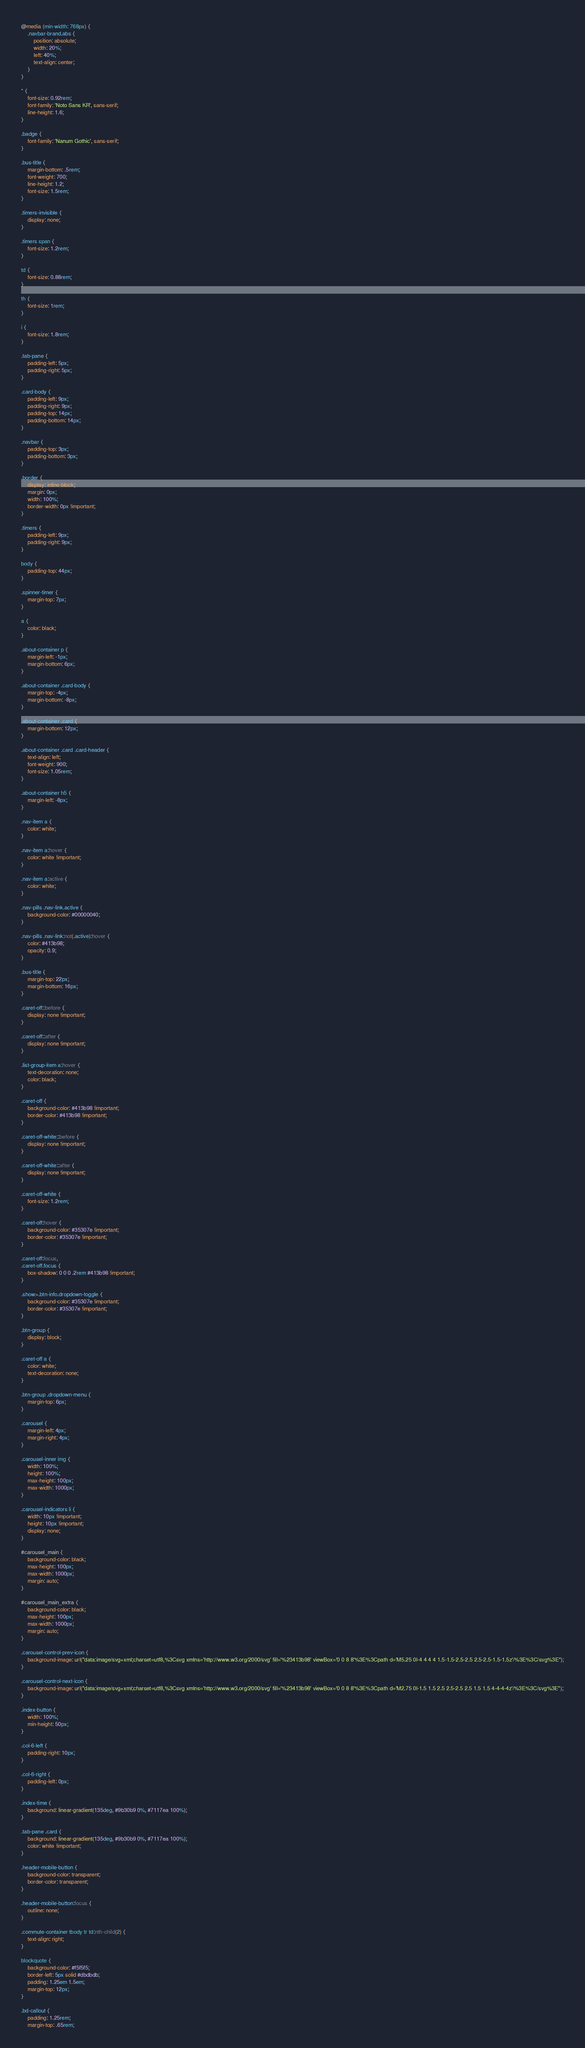Convert code to text. <code><loc_0><loc_0><loc_500><loc_500><_CSS_>@media (min-width: 768px) {
    .navbar-brand.abs {
        position: absolute;
        width: 20%;
        left: 40%;
        text-align: center;
    }
}

* {
    font-size: 0.92rem;
    font-family: 'Noto Sans KR', sans-serif;
    line-height: 1.6;
}

.badge {
    font-family: 'Nanum Gothic', sans-serif;
}

.bus-title {
    margin-bottom: .5rem;
    font-weight: 700;
    line-height: 1.2;
    font-size: 1.5rem;
}

.timers-invisible {
    display: none;
}

.timers span {
    font-size: 1.2rem;
}

td {
    font-size: 0.88rem;
}

th {
    font-size: 1rem;
}

i {
    font-size: 1.8rem;
}

.tab-pane {
    padding-left: 5px;
    padding-right: 5px;
}

.card-body {
    padding-left: 9px;
    padding-right: 9px;
    padding-top: 14px;
    padding-bottom: 14px;
}

.navbar {
    padding-top: 3px;
    padding-bottom: 3px;
}

.border {
    display: inline-block;
    margin: 0px;
    width: 100%;
    border-width: 0px !important;
}

.timers {
    padding-left: 9px;
    padding-right: 9px;
}

body {
    padding-top: 44px;
}

.spinner-timer {
    margin-top: 7px;
}

a {
    color: black;
}

.about-container p {
    margin-left: -1px;
    margin-bottom: 6px;
}

.about-container .card-body {
    margin-top: -4px;
    margin-bottom: -8px;
}

.about-container .card {
    margin-bottom: 12px;
}

.about-container .card .card-header {
    text-align: left;
    font-weight: 900;
    font-size: 1.05rem;
}

.about-container h5 {
    margin-left: -8px;
}

.nav-item a {
    color: white;
}

.nav-item a:hover {
    color: white !important;
}

.nav-item a:active {
    color: white;
}

.nav-pills .nav-link.active {
    background-color: #00000040;
}

.nav-pills .nav-link:not(.active):hover {
    color: #413b98;
    opacity: 0.9;
}

.bus-title {
    margin-top: 22px;
    margin-bottom: 16px;
}

.caret-off::before {
    display: none !important;
}

.caret-off::after {
    display: none !important;
}

.list-group-item a:hover {
    text-decoration: none;
    color: black;
}

.caret-off {
    background-color: #413b98 !important;
    border-color: #413b98 !important;
}

.caret-off-white::before {
    display: none !important;
}

.caret-off-white::after {
    display: none !important;
}

.caret-off-white {
    font-size: 1.2rem;
}

.caret-off:hover {
    background-color: #35307e !important;
    border-color: #35307e !important;
}

.caret-off:focus,
.caret-off.focus {
    box-shadow: 0 0 0 .2rem #413b98 !important;
}

.show>.btn-info.dropdown-toggle {
    background-color: #35307e !important;
    border-color: #35307e !important;
}

.btn-group {
    display: block;
}

.caret-off a {
    color: white;
    text-decoration: none;
}

.btn-group .dropdown-menu {
    margin-top: 6px;
}

.carousel {
    margin-left: 4px;
    margin-right: 4px;
}

.carousel-inner img {
    width: 100%;
    height: 100%;
    max-height: 100px;
    max-width: 1000px;
}

.carousel-indicators li {
    width: 10px !important;
    height: 10px !important;
    display: none;
}

#carousel_main {
    background-color: black;
    max-height: 100px;
    max-width: 1000px;
    margin: auto;
}

#carousel_main_extra {
    background-color: black;
    max-height: 100px;
    max-width: 1000px;
    margin: auto;
}

.carousel-control-prev-icon {
    background-image: url("data:image/svg+xml;charset=utf8,%3Csvg xmlns='http://www.w3.org/2000/svg' fill='%23413b98' viewBox='0 0 8 8'%3E%3Cpath d='M5.25 0l-4 4 4 4 1.5-1.5-2.5-2.5 2.5-2.5-1.5-1.5z'/%3E%3C/svg%3E");
}

.carousel-control-next-icon {
    background-image: url("data:image/svg+xml;charset=utf8,%3Csvg xmlns='http://www.w3.org/2000/svg' fill='%23413b98' viewBox='0 0 8 8'%3E%3Cpath d='M2.75 0l-1.5 1.5 2.5 2.5-2.5 2.5 1.5 1.5 4-4-4-4z'/%3E%3C/svg%3E");
}

.index-button {
    width: 100%;
    min-height: 50px;
}

.col-6-left {
    padding-right: 10px;
}

.col-6-right {
    padding-left: 0px;
}

.index-time {
    background: linear-gradient(135deg, #9b30b9 0%, #7117ea 100%);
}

.tab-pane .card {
    background: linear-gradient(135deg, #9b30b9 0%, #7117ea 100%);
    color: white !important;
}

.header-mobile-button {
    background-color: transparent;
    border-color: transparent;
}

.header-mobile-button:focus {
    outline: none;
}

.commute-container tbody tr td:nth-child(2) {
    text-align: right;
}

blockquote {
    background-color: #f5f5f5;
    border-left: 5px solid #dbdbdb;
    padding: 1.25em 1.5em;
    margin-top: 12px;
}

.bd-callout {
    padding: 1.25rem;
    margin-top: .65rem;</code> 